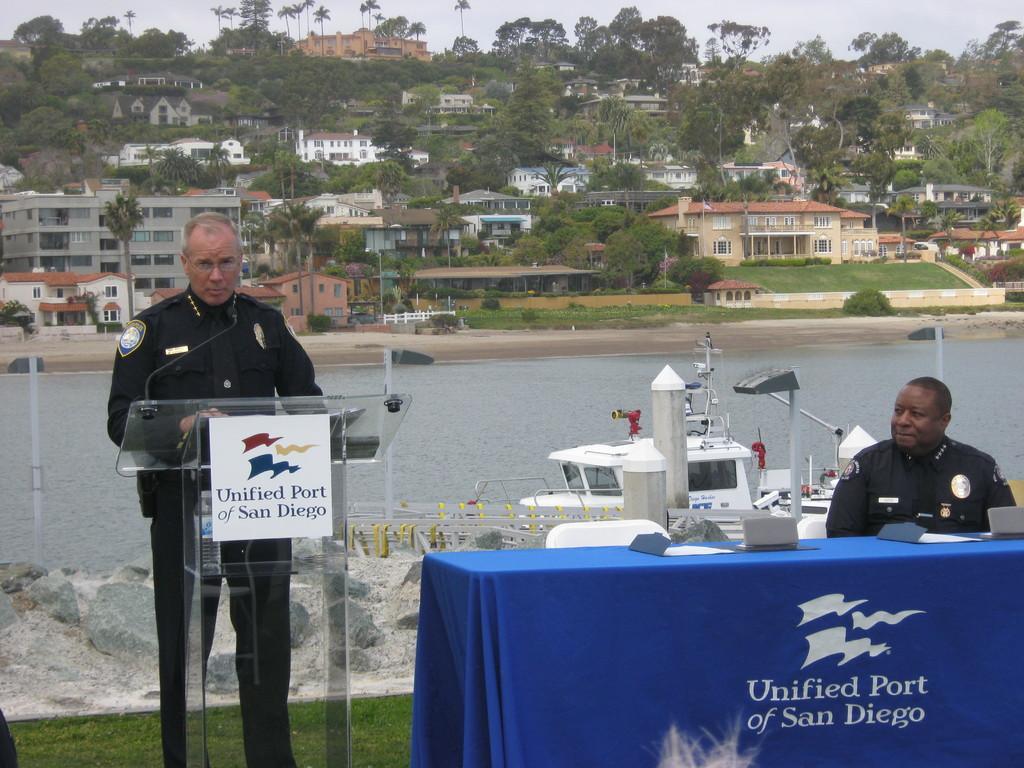Could you give a brief overview of what you see in this image? This is the picture of a city. In the foreground there is a person sitting behind the table and there is a person standing behind the podium and there is a microphone on the podium. At the back there is a boat on the water. At the back there are buildings and trees and poles. At the top there is sky. At the bottom there is water and sky. 